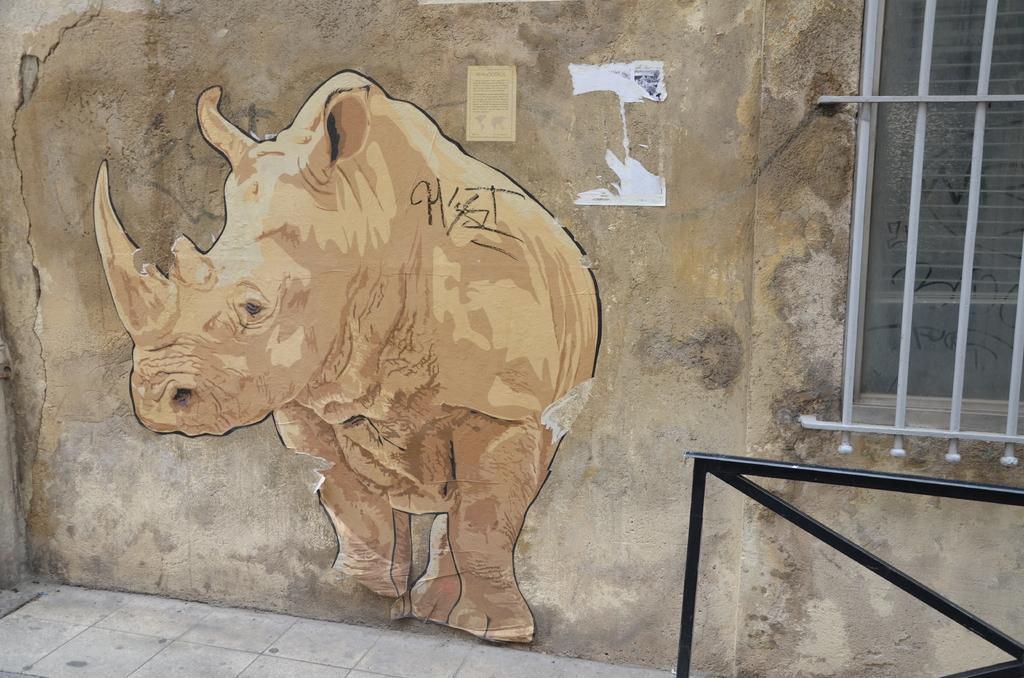Could you give a brief overview of what you see in this image? In this picture, we see a poster of rhinoceros is pasted on the wall. We even see a yellow color paper with text written on it is pasted on the wall. In the right bottom of the picture, we see an iron railing. On the right side, we see a window. 